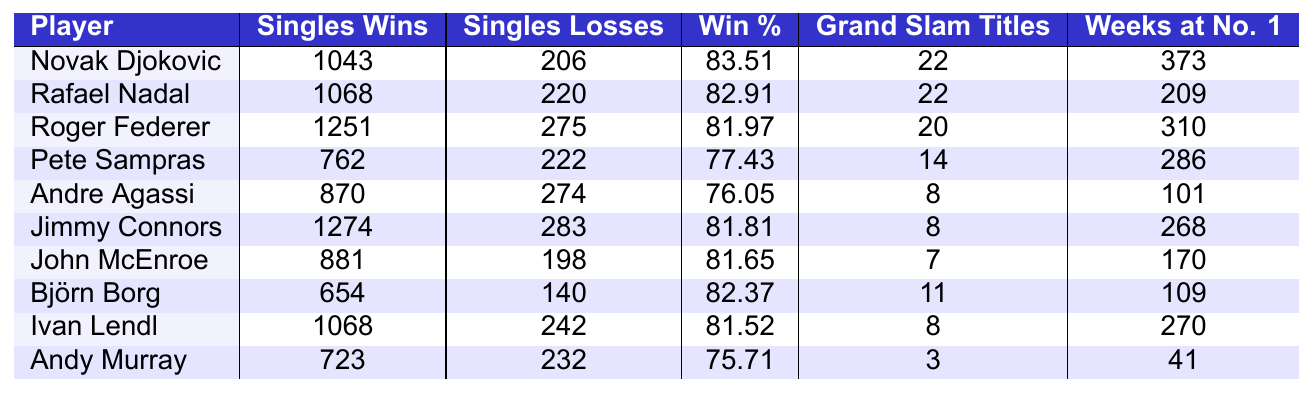What is the win percentage of Rafael Nadal? The win percentage is listed directly in the table under the "Win %" column for Rafael Nadal, which states 82.91%.
Answer: 82.91% Which player has the most singles wins? The table shows the singles wins for each player, with Jimmy Connors having the highest at 1274.
Answer: Jimmy Connors How many Grand Slam titles does Novak Djokovic have? The table displays the number of Grand Slam titles for each player, showing that Novak Djokovic has 22 titles.
Answer: 22 What is the total number of singles wins for Roger Federer and Pete Sampras combined? To find the total, sum the singles wins from the table: 1251 (Federer) + 762 (Sampras) = 2013.
Answer: 2013 Is Andy Murray's win percentage higher than that of Pete Sampras? Andy Murray's win percentage is 75.71% while Pete Sampras' is 77.43%. Since 75.71% is less than 77.43%, the statement is false.
Answer: No Who is the only player with fewer than 800 singles wins? Checking the table, only Andy Murray has fewer than 800 singles wins with a total of 723.
Answer: Andy Murray Calculate the average win percentage of the top 3 players. The win percentages for the top 3 players are 83.51% (Djokovic), 82.91% (Nadal), and 81.97% (Federer). Sum these: 83.51 + 82.91 + 81.97 = 248.39 and divide by 3, giving an average of 82.79667%.
Answer: Approximately 82.80% Which player has the highest number of weeks at No. 1? The table indicates that Novak Djokovic has the highest number of weeks at No. 1 with 373 weeks.
Answer: Novak Djokovic What is the difference in singles losses between Jimmy Connors and John McEnroe? Jimmy Connors has 283 losses and John McEnroe has 198 losses. Subtracting gives: 283 - 198 = 85.
Answer: 85 Do both Rafael Nadal and Ivan Lendl have the same number of Grand Slam titles? According to the table, both Rafael Nadal and Ivan Lendl have 22 and 8 Grand Slam titles respectively, indicating they do not have the same number.
Answer: No 